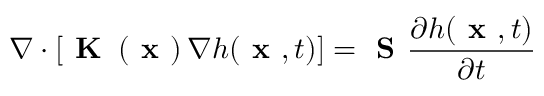<formula> <loc_0><loc_0><loc_500><loc_500>\nabla \cdot \left [ K \left ( x \right ) \nabla h ( x , t ) \right ] = S \frac { \partial h ( x , t ) } { \partial t }</formula> 